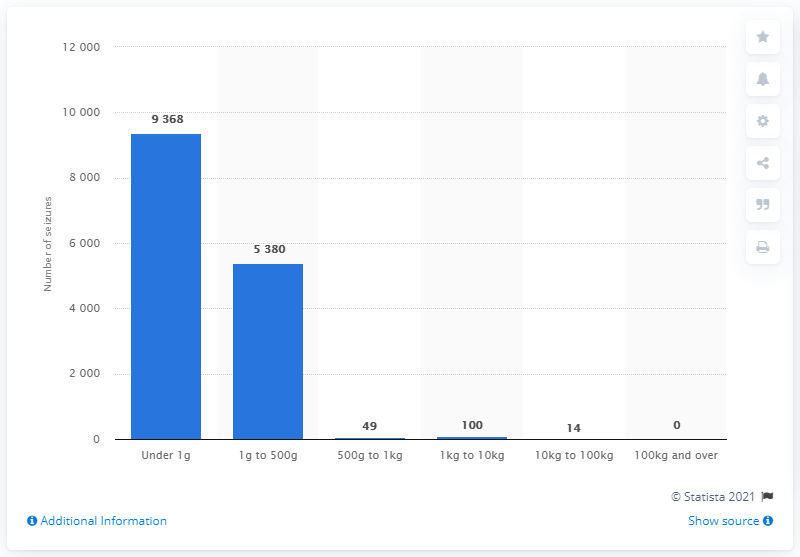Outline some significant characteristics in this image. The number of cocaine seizures that occurred between 10 and 100 kilograms is 14. 